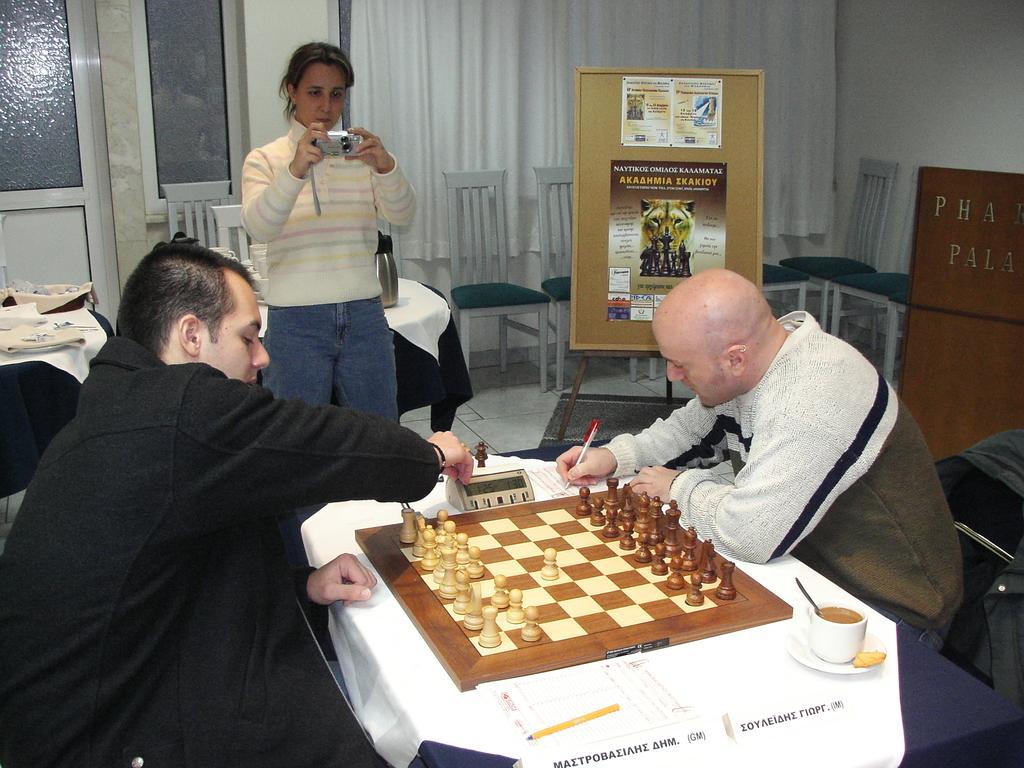Could you give a brief overview of what you see in this image? In this image two persons are sitting on a chair and both of them are playing a chess. On the left there is a person who is wearing a black dress is holding a clock. And on the right person, he is writing something on a paper. There is a woman who is holding a camera and shooting a game. Besides her there is a banner which showing a picture of a lion. On the left we can see door and besides it there is a window. On the table there is a towel and it's covered by the cloth. 